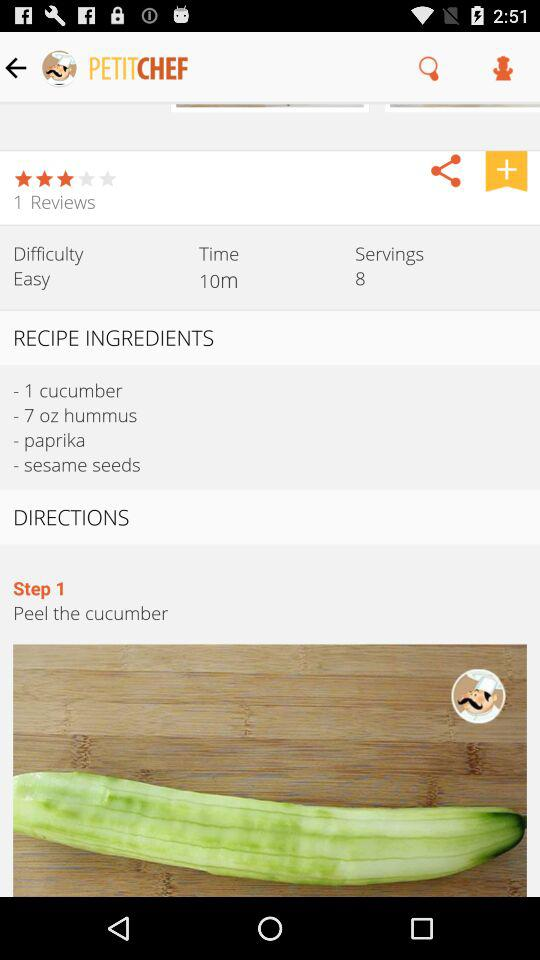How many reviews are there for the dish? There is 1 review for the dish. 